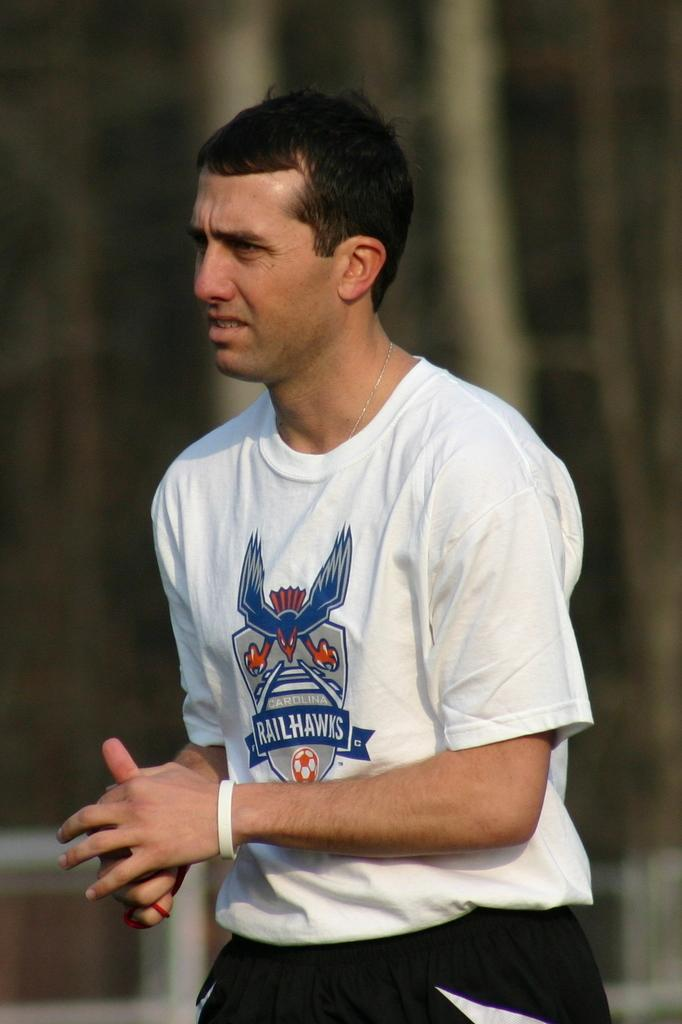<image>
Relay a brief, clear account of the picture shown. A black haired white man in a white Caroline Railhawks t-shirt. 